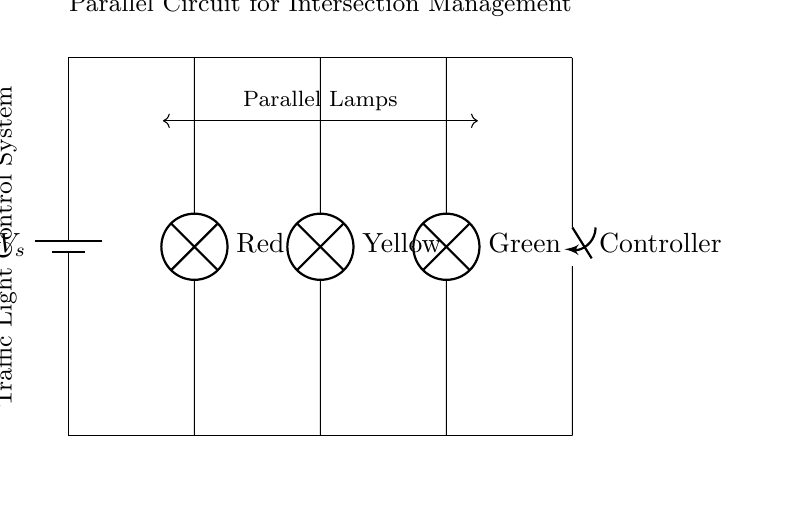What components are included in this circuit? The circuit includes a battery, three lamps (Red, Yellow, Green), and a controller switch. These components are directly identifiable on the circuit diagram.
Answer: battery, lamps, controller switch How are the lamps connected in this circuit? The lamps are connected in a parallel configuration, indicated by the branches emanating from a single voltage source, allowing each lamp to operate independently.
Answer: in parallel What is the purpose of the controller switch? The controller switch is used to manage the operation of the entire traffic light system, controlling which lamps are illuminated.
Answer: to control the lights What would happen if one lamp fails in this circuit? If one lamp fails, the other lamps would still function because they are connected in parallel, maintaining operation of the traffic lights.
Answer: other lamps continue working What is the significance of using a parallel circuit in traffic lights? Using a parallel circuit allows each light to operate independently, ensuring continuous traffic management even if one light fails, providing reliability in intersection management.
Answer: reliability What voltage is provided by the battery? The voltage of the battery is indicated as V_s in the diagram, typically referring to the supply voltage necessary to power the lamps and controller.
Answer: V_s How many lamps are present in this circuit? The circuit contains three lamps: Red, Yellow, and Green, which correspond to standard traffic light colors.
Answer: three lamps 